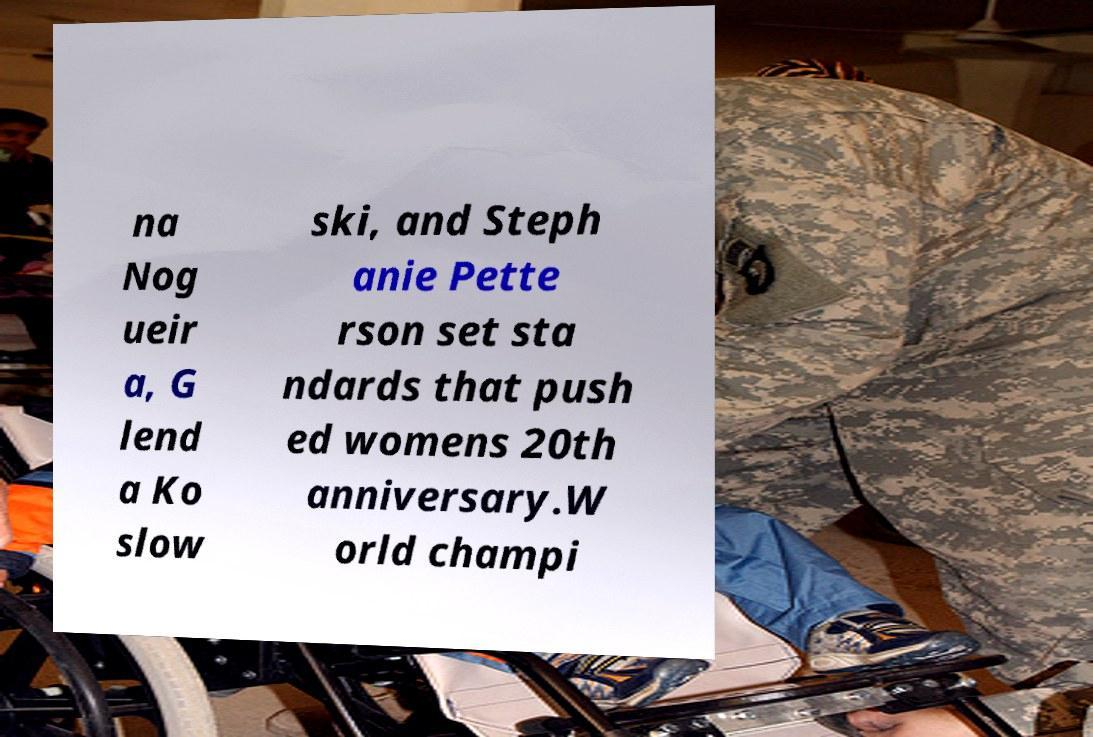Can you accurately transcribe the text from the provided image for me? na Nog ueir a, G lend a Ko slow ski, and Steph anie Pette rson set sta ndards that push ed womens 20th anniversary.W orld champi 